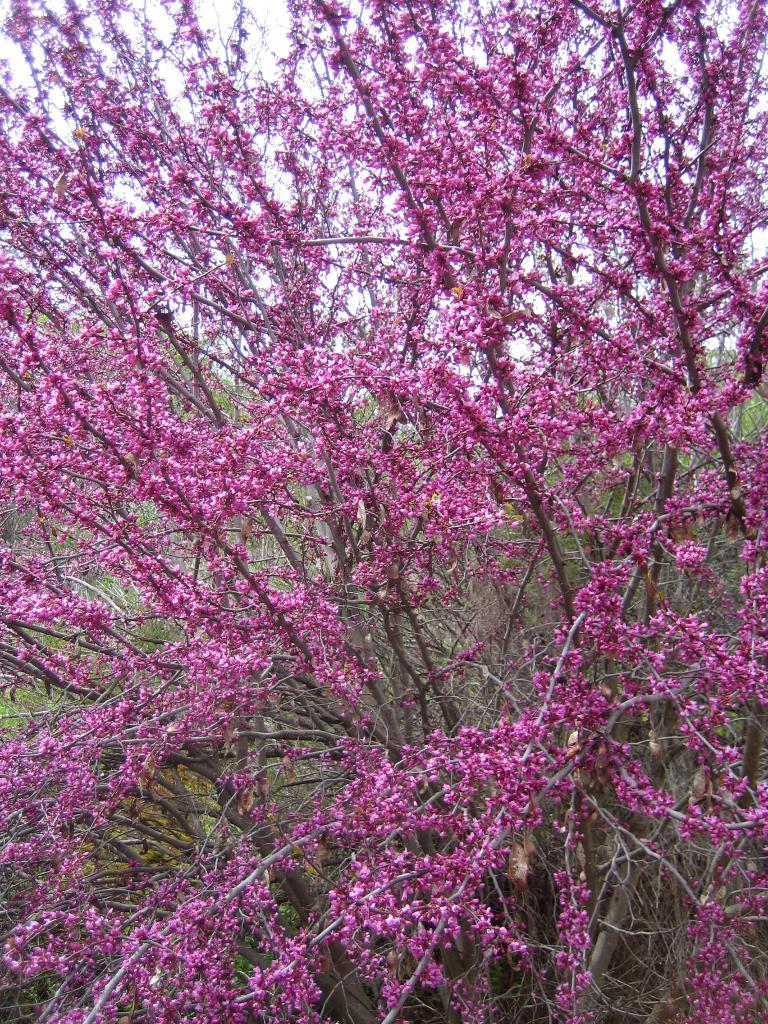What type of vegetation can be seen in the image? There are trees in the image. What other natural elements are present in the image? There are flowers in the image. What can be seen in the background of the image? The sky is visible in the background of the image. How many fish can be seen swimming in the image? There are no fish present in the image; it features trees, flowers, and the sky. 